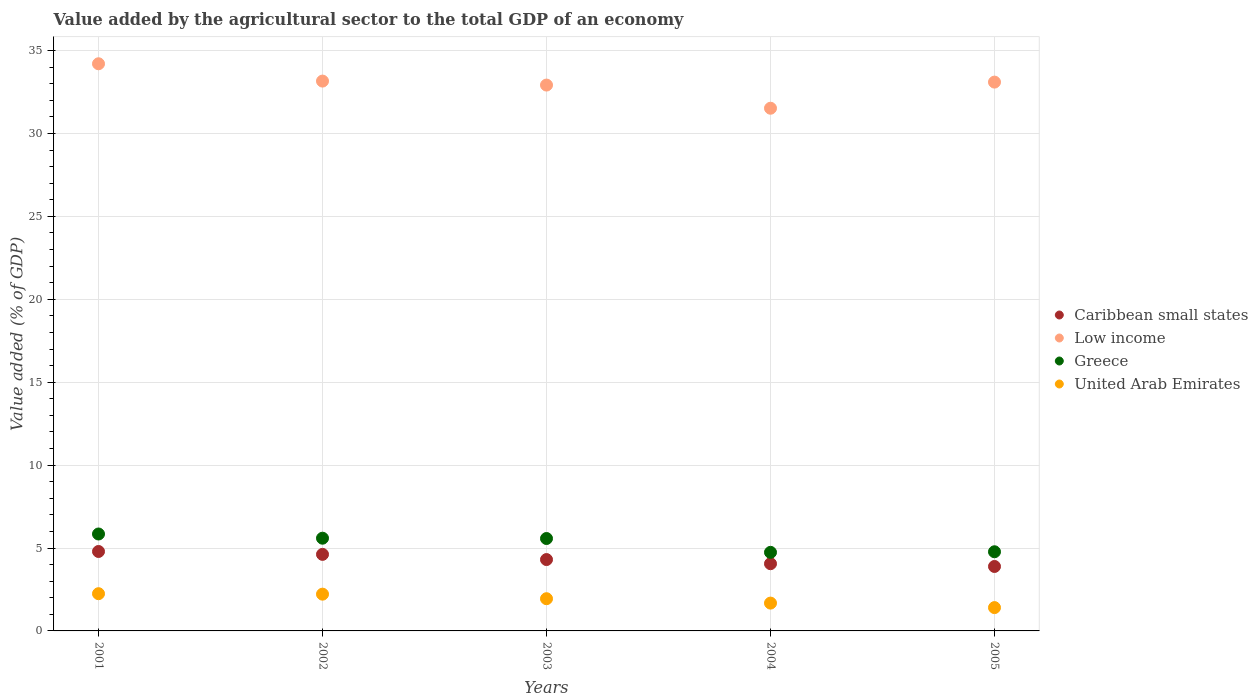How many different coloured dotlines are there?
Offer a terse response. 4. Is the number of dotlines equal to the number of legend labels?
Offer a terse response. Yes. What is the value added by the agricultural sector to the total GDP in Low income in 2005?
Offer a terse response. 33.1. Across all years, what is the maximum value added by the agricultural sector to the total GDP in Caribbean small states?
Your answer should be compact. 4.79. Across all years, what is the minimum value added by the agricultural sector to the total GDP in Caribbean small states?
Give a very brief answer. 3.89. In which year was the value added by the agricultural sector to the total GDP in United Arab Emirates maximum?
Make the answer very short. 2001. What is the total value added by the agricultural sector to the total GDP in Low income in the graph?
Keep it short and to the point. 164.89. What is the difference between the value added by the agricultural sector to the total GDP in Greece in 2003 and that in 2005?
Offer a terse response. 0.8. What is the difference between the value added by the agricultural sector to the total GDP in Caribbean small states in 2002 and the value added by the agricultural sector to the total GDP in Low income in 2005?
Keep it short and to the point. -28.48. What is the average value added by the agricultural sector to the total GDP in Low income per year?
Provide a succinct answer. 32.98. In the year 2003, what is the difference between the value added by the agricultural sector to the total GDP in Greece and value added by the agricultural sector to the total GDP in United Arab Emirates?
Make the answer very short. 3.63. In how many years, is the value added by the agricultural sector to the total GDP in Caribbean small states greater than 22 %?
Your response must be concise. 0. What is the ratio of the value added by the agricultural sector to the total GDP in Caribbean small states in 2002 to that in 2004?
Offer a terse response. 1.14. Is the value added by the agricultural sector to the total GDP in Caribbean small states in 2001 less than that in 2004?
Your answer should be very brief. No. What is the difference between the highest and the second highest value added by the agricultural sector to the total GDP in Greece?
Give a very brief answer. 0.25. What is the difference between the highest and the lowest value added by the agricultural sector to the total GDP in United Arab Emirates?
Keep it short and to the point. 0.84. In how many years, is the value added by the agricultural sector to the total GDP in Caribbean small states greater than the average value added by the agricultural sector to the total GDP in Caribbean small states taken over all years?
Provide a succinct answer. 2. Is the sum of the value added by the agricultural sector to the total GDP in United Arab Emirates in 2002 and 2005 greater than the maximum value added by the agricultural sector to the total GDP in Caribbean small states across all years?
Give a very brief answer. No. Is it the case that in every year, the sum of the value added by the agricultural sector to the total GDP in Greece and value added by the agricultural sector to the total GDP in United Arab Emirates  is greater than the sum of value added by the agricultural sector to the total GDP in Low income and value added by the agricultural sector to the total GDP in Caribbean small states?
Ensure brevity in your answer.  Yes. Does the value added by the agricultural sector to the total GDP in Greece monotonically increase over the years?
Give a very brief answer. No. Are the values on the major ticks of Y-axis written in scientific E-notation?
Offer a terse response. No. Where does the legend appear in the graph?
Your answer should be compact. Center right. How many legend labels are there?
Offer a terse response. 4. How are the legend labels stacked?
Your response must be concise. Vertical. What is the title of the graph?
Ensure brevity in your answer.  Value added by the agricultural sector to the total GDP of an economy. Does "Central African Republic" appear as one of the legend labels in the graph?
Ensure brevity in your answer.  No. What is the label or title of the Y-axis?
Your answer should be compact. Value added (% of GDP). What is the Value added (% of GDP) in Caribbean small states in 2001?
Offer a terse response. 4.79. What is the Value added (% of GDP) of Low income in 2001?
Offer a terse response. 34.2. What is the Value added (% of GDP) of Greece in 2001?
Provide a short and direct response. 5.84. What is the Value added (% of GDP) of United Arab Emirates in 2001?
Your answer should be compact. 2.25. What is the Value added (% of GDP) in Caribbean small states in 2002?
Your response must be concise. 4.62. What is the Value added (% of GDP) in Low income in 2002?
Provide a succinct answer. 33.16. What is the Value added (% of GDP) in Greece in 2002?
Provide a short and direct response. 5.59. What is the Value added (% of GDP) in United Arab Emirates in 2002?
Your answer should be compact. 2.22. What is the Value added (% of GDP) of Caribbean small states in 2003?
Offer a very short reply. 4.3. What is the Value added (% of GDP) of Low income in 2003?
Your answer should be very brief. 32.92. What is the Value added (% of GDP) of Greece in 2003?
Offer a very short reply. 5.57. What is the Value added (% of GDP) in United Arab Emirates in 2003?
Your response must be concise. 1.94. What is the Value added (% of GDP) in Caribbean small states in 2004?
Your answer should be compact. 4.05. What is the Value added (% of GDP) in Low income in 2004?
Your answer should be compact. 31.52. What is the Value added (% of GDP) of Greece in 2004?
Make the answer very short. 4.74. What is the Value added (% of GDP) of United Arab Emirates in 2004?
Give a very brief answer. 1.68. What is the Value added (% of GDP) in Caribbean small states in 2005?
Your response must be concise. 3.89. What is the Value added (% of GDP) in Low income in 2005?
Give a very brief answer. 33.1. What is the Value added (% of GDP) of Greece in 2005?
Your response must be concise. 4.77. What is the Value added (% of GDP) of United Arab Emirates in 2005?
Ensure brevity in your answer.  1.41. Across all years, what is the maximum Value added (% of GDP) in Caribbean small states?
Your response must be concise. 4.79. Across all years, what is the maximum Value added (% of GDP) in Low income?
Offer a terse response. 34.2. Across all years, what is the maximum Value added (% of GDP) in Greece?
Your response must be concise. 5.84. Across all years, what is the maximum Value added (% of GDP) of United Arab Emirates?
Ensure brevity in your answer.  2.25. Across all years, what is the minimum Value added (% of GDP) in Caribbean small states?
Your answer should be compact. 3.89. Across all years, what is the minimum Value added (% of GDP) of Low income?
Your answer should be very brief. 31.52. Across all years, what is the minimum Value added (% of GDP) in Greece?
Give a very brief answer. 4.74. Across all years, what is the minimum Value added (% of GDP) of United Arab Emirates?
Ensure brevity in your answer.  1.41. What is the total Value added (% of GDP) in Caribbean small states in the graph?
Give a very brief answer. 21.65. What is the total Value added (% of GDP) in Low income in the graph?
Offer a very short reply. 164.89. What is the total Value added (% of GDP) of Greece in the graph?
Offer a very short reply. 26.52. What is the total Value added (% of GDP) in United Arab Emirates in the graph?
Offer a terse response. 9.49. What is the difference between the Value added (% of GDP) of Caribbean small states in 2001 and that in 2002?
Give a very brief answer. 0.17. What is the difference between the Value added (% of GDP) in Low income in 2001 and that in 2002?
Keep it short and to the point. 1.04. What is the difference between the Value added (% of GDP) in Greece in 2001 and that in 2002?
Make the answer very short. 0.25. What is the difference between the Value added (% of GDP) in United Arab Emirates in 2001 and that in 2002?
Offer a very short reply. 0.03. What is the difference between the Value added (% of GDP) of Caribbean small states in 2001 and that in 2003?
Ensure brevity in your answer.  0.49. What is the difference between the Value added (% of GDP) of Low income in 2001 and that in 2003?
Provide a succinct answer. 1.28. What is the difference between the Value added (% of GDP) in Greece in 2001 and that in 2003?
Give a very brief answer. 0.27. What is the difference between the Value added (% of GDP) of United Arab Emirates in 2001 and that in 2003?
Your answer should be very brief. 0.3. What is the difference between the Value added (% of GDP) in Caribbean small states in 2001 and that in 2004?
Keep it short and to the point. 0.74. What is the difference between the Value added (% of GDP) in Low income in 2001 and that in 2004?
Make the answer very short. 2.68. What is the difference between the Value added (% of GDP) of Greece in 2001 and that in 2004?
Make the answer very short. 1.11. What is the difference between the Value added (% of GDP) in United Arab Emirates in 2001 and that in 2004?
Offer a very short reply. 0.57. What is the difference between the Value added (% of GDP) of Caribbean small states in 2001 and that in 2005?
Give a very brief answer. 0.9. What is the difference between the Value added (% of GDP) in Low income in 2001 and that in 2005?
Ensure brevity in your answer.  1.11. What is the difference between the Value added (% of GDP) in Greece in 2001 and that in 2005?
Provide a short and direct response. 1.07. What is the difference between the Value added (% of GDP) of United Arab Emirates in 2001 and that in 2005?
Your answer should be very brief. 0.84. What is the difference between the Value added (% of GDP) of Caribbean small states in 2002 and that in 2003?
Your response must be concise. 0.31. What is the difference between the Value added (% of GDP) in Low income in 2002 and that in 2003?
Offer a very short reply. 0.24. What is the difference between the Value added (% of GDP) of Greece in 2002 and that in 2003?
Offer a very short reply. 0.02. What is the difference between the Value added (% of GDP) in United Arab Emirates in 2002 and that in 2003?
Give a very brief answer. 0.27. What is the difference between the Value added (% of GDP) in Caribbean small states in 2002 and that in 2004?
Your response must be concise. 0.56. What is the difference between the Value added (% of GDP) of Low income in 2002 and that in 2004?
Keep it short and to the point. 1.64. What is the difference between the Value added (% of GDP) in Greece in 2002 and that in 2004?
Your answer should be very brief. 0.85. What is the difference between the Value added (% of GDP) of United Arab Emirates in 2002 and that in 2004?
Your response must be concise. 0.54. What is the difference between the Value added (% of GDP) in Caribbean small states in 2002 and that in 2005?
Provide a short and direct response. 0.73. What is the difference between the Value added (% of GDP) of Low income in 2002 and that in 2005?
Ensure brevity in your answer.  0.06. What is the difference between the Value added (% of GDP) of Greece in 2002 and that in 2005?
Your response must be concise. 0.82. What is the difference between the Value added (% of GDP) of United Arab Emirates in 2002 and that in 2005?
Ensure brevity in your answer.  0.81. What is the difference between the Value added (% of GDP) of Caribbean small states in 2003 and that in 2004?
Provide a succinct answer. 0.25. What is the difference between the Value added (% of GDP) in Low income in 2003 and that in 2004?
Ensure brevity in your answer.  1.4. What is the difference between the Value added (% of GDP) of Greece in 2003 and that in 2004?
Keep it short and to the point. 0.83. What is the difference between the Value added (% of GDP) in United Arab Emirates in 2003 and that in 2004?
Keep it short and to the point. 0.26. What is the difference between the Value added (% of GDP) of Caribbean small states in 2003 and that in 2005?
Ensure brevity in your answer.  0.42. What is the difference between the Value added (% of GDP) of Low income in 2003 and that in 2005?
Your answer should be compact. -0.18. What is the difference between the Value added (% of GDP) in Greece in 2003 and that in 2005?
Keep it short and to the point. 0.8. What is the difference between the Value added (% of GDP) in United Arab Emirates in 2003 and that in 2005?
Provide a short and direct response. 0.54. What is the difference between the Value added (% of GDP) in Caribbean small states in 2004 and that in 2005?
Provide a short and direct response. 0.17. What is the difference between the Value added (% of GDP) of Low income in 2004 and that in 2005?
Keep it short and to the point. -1.58. What is the difference between the Value added (% of GDP) of Greece in 2004 and that in 2005?
Make the answer very short. -0.03. What is the difference between the Value added (% of GDP) of United Arab Emirates in 2004 and that in 2005?
Your response must be concise. 0.27. What is the difference between the Value added (% of GDP) in Caribbean small states in 2001 and the Value added (% of GDP) in Low income in 2002?
Offer a terse response. -28.37. What is the difference between the Value added (% of GDP) in Caribbean small states in 2001 and the Value added (% of GDP) in Greece in 2002?
Your answer should be very brief. -0.8. What is the difference between the Value added (% of GDP) of Caribbean small states in 2001 and the Value added (% of GDP) of United Arab Emirates in 2002?
Ensure brevity in your answer.  2.57. What is the difference between the Value added (% of GDP) of Low income in 2001 and the Value added (% of GDP) of Greece in 2002?
Offer a terse response. 28.61. What is the difference between the Value added (% of GDP) in Low income in 2001 and the Value added (% of GDP) in United Arab Emirates in 2002?
Offer a very short reply. 31.98. What is the difference between the Value added (% of GDP) of Greece in 2001 and the Value added (% of GDP) of United Arab Emirates in 2002?
Provide a short and direct response. 3.63. What is the difference between the Value added (% of GDP) of Caribbean small states in 2001 and the Value added (% of GDP) of Low income in 2003?
Provide a short and direct response. -28.13. What is the difference between the Value added (% of GDP) of Caribbean small states in 2001 and the Value added (% of GDP) of Greece in 2003?
Provide a succinct answer. -0.78. What is the difference between the Value added (% of GDP) of Caribbean small states in 2001 and the Value added (% of GDP) of United Arab Emirates in 2003?
Your answer should be very brief. 2.85. What is the difference between the Value added (% of GDP) of Low income in 2001 and the Value added (% of GDP) of Greece in 2003?
Your answer should be compact. 28.63. What is the difference between the Value added (% of GDP) in Low income in 2001 and the Value added (% of GDP) in United Arab Emirates in 2003?
Provide a succinct answer. 32.26. What is the difference between the Value added (% of GDP) of Greece in 2001 and the Value added (% of GDP) of United Arab Emirates in 2003?
Ensure brevity in your answer.  3.9. What is the difference between the Value added (% of GDP) in Caribbean small states in 2001 and the Value added (% of GDP) in Low income in 2004?
Your answer should be compact. -26.73. What is the difference between the Value added (% of GDP) in Caribbean small states in 2001 and the Value added (% of GDP) in Greece in 2004?
Provide a succinct answer. 0.05. What is the difference between the Value added (% of GDP) of Caribbean small states in 2001 and the Value added (% of GDP) of United Arab Emirates in 2004?
Your answer should be very brief. 3.11. What is the difference between the Value added (% of GDP) of Low income in 2001 and the Value added (% of GDP) of Greece in 2004?
Your answer should be compact. 29.46. What is the difference between the Value added (% of GDP) of Low income in 2001 and the Value added (% of GDP) of United Arab Emirates in 2004?
Make the answer very short. 32.52. What is the difference between the Value added (% of GDP) in Greece in 2001 and the Value added (% of GDP) in United Arab Emirates in 2004?
Make the answer very short. 4.17. What is the difference between the Value added (% of GDP) of Caribbean small states in 2001 and the Value added (% of GDP) of Low income in 2005?
Offer a very short reply. -28.31. What is the difference between the Value added (% of GDP) in Caribbean small states in 2001 and the Value added (% of GDP) in Greece in 2005?
Your answer should be compact. 0.02. What is the difference between the Value added (% of GDP) in Caribbean small states in 2001 and the Value added (% of GDP) in United Arab Emirates in 2005?
Offer a very short reply. 3.38. What is the difference between the Value added (% of GDP) in Low income in 2001 and the Value added (% of GDP) in Greece in 2005?
Your response must be concise. 29.43. What is the difference between the Value added (% of GDP) of Low income in 2001 and the Value added (% of GDP) of United Arab Emirates in 2005?
Offer a terse response. 32.8. What is the difference between the Value added (% of GDP) of Greece in 2001 and the Value added (% of GDP) of United Arab Emirates in 2005?
Keep it short and to the point. 4.44. What is the difference between the Value added (% of GDP) of Caribbean small states in 2002 and the Value added (% of GDP) of Low income in 2003?
Your response must be concise. -28.3. What is the difference between the Value added (% of GDP) in Caribbean small states in 2002 and the Value added (% of GDP) in Greece in 2003?
Give a very brief answer. -0.96. What is the difference between the Value added (% of GDP) in Caribbean small states in 2002 and the Value added (% of GDP) in United Arab Emirates in 2003?
Ensure brevity in your answer.  2.67. What is the difference between the Value added (% of GDP) of Low income in 2002 and the Value added (% of GDP) of Greece in 2003?
Provide a succinct answer. 27.58. What is the difference between the Value added (% of GDP) in Low income in 2002 and the Value added (% of GDP) in United Arab Emirates in 2003?
Make the answer very short. 31.21. What is the difference between the Value added (% of GDP) in Greece in 2002 and the Value added (% of GDP) in United Arab Emirates in 2003?
Your response must be concise. 3.65. What is the difference between the Value added (% of GDP) of Caribbean small states in 2002 and the Value added (% of GDP) of Low income in 2004?
Give a very brief answer. -26.9. What is the difference between the Value added (% of GDP) in Caribbean small states in 2002 and the Value added (% of GDP) in Greece in 2004?
Offer a terse response. -0.12. What is the difference between the Value added (% of GDP) in Caribbean small states in 2002 and the Value added (% of GDP) in United Arab Emirates in 2004?
Ensure brevity in your answer.  2.94. What is the difference between the Value added (% of GDP) of Low income in 2002 and the Value added (% of GDP) of Greece in 2004?
Ensure brevity in your answer.  28.42. What is the difference between the Value added (% of GDP) of Low income in 2002 and the Value added (% of GDP) of United Arab Emirates in 2004?
Offer a terse response. 31.48. What is the difference between the Value added (% of GDP) of Greece in 2002 and the Value added (% of GDP) of United Arab Emirates in 2004?
Your answer should be very brief. 3.91. What is the difference between the Value added (% of GDP) of Caribbean small states in 2002 and the Value added (% of GDP) of Low income in 2005?
Offer a terse response. -28.48. What is the difference between the Value added (% of GDP) in Caribbean small states in 2002 and the Value added (% of GDP) in Greece in 2005?
Give a very brief answer. -0.16. What is the difference between the Value added (% of GDP) of Caribbean small states in 2002 and the Value added (% of GDP) of United Arab Emirates in 2005?
Offer a terse response. 3.21. What is the difference between the Value added (% of GDP) in Low income in 2002 and the Value added (% of GDP) in Greece in 2005?
Your answer should be very brief. 28.38. What is the difference between the Value added (% of GDP) of Low income in 2002 and the Value added (% of GDP) of United Arab Emirates in 2005?
Give a very brief answer. 31.75. What is the difference between the Value added (% of GDP) in Greece in 2002 and the Value added (% of GDP) in United Arab Emirates in 2005?
Ensure brevity in your answer.  4.19. What is the difference between the Value added (% of GDP) of Caribbean small states in 2003 and the Value added (% of GDP) of Low income in 2004?
Your answer should be compact. -27.22. What is the difference between the Value added (% of GDP) of Caribbean small states in 2003 and the Value added (% of GDP) of Greece in 2004?
Your response must be concise. -0.44. What is the difference between the Value added (% of GDP) in Caribbean small states in 2003 and the Value added (% of GDP) in United Arab Emirates in 2004?
Your answer should be compact. 2.63. What is the difference between the Value added (% of GDP) in Low income in 2003 and the Value added (% of GDP) in Greece in 2004?
Your answer should be very brief. 28.18. What is the difference between the Value added (% of GDP) of Low income in 2003 and the Value added (% of GDP) of United Arab Emirates in 2004?
Keep it short and to the point. 31.24. What is the difference between the Value added (% of GDP) of Greece in 2003 and the Value added (% of GDP) of United Arab Emirates in 2004?
Give a very brief answer. 3.9. What is the difference between the Value added (% of GDP) of Caribbean small states in 2003 and the Value added (% of GDP) of Low income in 2005?
Your answer should be compact. -28.79. What is the difference between the Value added (% of GDP) in Caribbean small states in 2003 and the Value added (% of GDP) in Greece in 2005?
Your answer should be very brief. -0.47. What is the difference between the Value added (% of GDP) in Caribbean small states in 2003 and the Value added (% of GDP) in United Arab Emirates in 2005?
Your response must be concise. 2.9. What is the difference between the Value added (% of GDP) in Low income in 2003 and the Value added (% of GDP) in Greece in 2005?
Your response must be concise. 28.14. What is the difference between the Value added (% of GDP) of Low income in 2003 and the Value added (% of GDP) of United Arab Emirates in 2005?
Give a very brief answer. 31.51. What is the difference between the Value added (% of GDP) in Greece in 2003 and the Value added (% of GDP) in United Arab Emirates in 2005?
Your answer should be very brief. 4.17. What is the difference between the Value added (% of GDP) in Caribbean small states in 2004 and the Value added (% of GDP) in Low income in 2005?
Provide a short and direct response. -29.04. What is the difference between the Value added (% of GDP) of Caribbean small states in 2004 and the Value added (% of GDP) of Greece in 2005?
Keep it short and to the point. -0.72. What is the difference between the Value added (% of GDP) in Caribbean small states in 2004 and the Value added (% of GDP) in United Arab Emirates in 2005?
Offer a very short reply. 2.65. What is the difference between the Value added (% of GDP) in Low income in 2004 and the Value added (% of GDP) in Greece in 2005?
Give a very brief answer. 26.75. What is the difference between the Value added (% of GDP) of Low income in 2004 and the Value added (% of GDP) of United Arab Emirates in 2005?
Make the answer very short. 30.11. What is the difference between the Value added (% of GDP) in Greece in 2004 and the Value added (% of GDP) in United Arab Emirates in 2005?
Give a very brief answer. 3.33. What is the average Value added (% of GDP) in Caribbean small states per year?
Provide a succinct answer. 4.33. What is the average Value added (% of GDP) of Low income per year?
Keep it short and to the point. 32.98. What is the average Value added (% of GDP) in Greece per year?
Your answer should be very brief. 5.3. What is the average Value added (% of GDP) in United Arab Emirates per year?
Give a very brief answer. 1.9. In the year 2001, what is the difference between the Value added (% of GDP) in Caribbean small states and Value added (% of GDP) in Low income?
Your answer should be very brief. -29.41. In the year 2001, what is the difference between the Value added (% of GDP) of Caribbean small states and Value added (% of GDP) of Greece?
Provide a short and direct response. -1.05. In the year 2001, what is the difference between the Value added (% of GDP) in Caribbean small states and Value added (% of GDP) in United Arab Emirates?
Offer a very short reply. 2.55. In the year 2001, what is the difference between the Value added (% of GDP) in Low income and Value added (% of GDP) in Greece?
Keep it short and to the point. 28.36. In the year 2001, what is the difference between the Value added (% of GDP) in Low income and Value added (% of GDP) in United Arab Emirates?
Offer a very short reply. 31.96. In the year 2001, what is the difference between the Value added (% of GDP) of Greece and Value added (% of GDP) of United Arab Emirates?
Your answer should be very brief. 3.6. In the year 2002, what is the difference between the Value added (% of GDP) in Caribbean small states and Value added (% of GDP) in Low income?
Keep it short and to the point. -28.54. In the year 2002, what is the difference between the Value added (% of GDP) in Caribbean small states and Value added (% of GDP) in Greece?
Make the answer very short. -0.98. In the year 2002, what is the difference between the Value added (% of GDP) in Caribbean small states and Value added (% of GDP) in United Arab Emirates?
Offer a terse response. 2.4. In the year 2002, what is the difference between the Value added (% of GDP) of Low income and Value added (% of GDP) of Greece?
Your answer should be compact. 27.57. In the year 2002, what is the difference between the Value added (% of GDP) of Low income and Value added (% of GDP) of United Arab Emirates?
Keep it short and to the point. 30.94. In the year 2002, what is the difference between the Value added (% of GDP) in Greece and Value added (% of GDP) in United Arab Emirates?
Your response must be concise. 3.37. In the year 2003, what is the difference between the Value added (% of GDP) of Caribbean small states and Value added (% of GDP) of Low income?
Offer a terse response. -28.61. In the year 2003, what is the difference between the Value added (% of GDP) in Caribbean small states and Value added (% of GDP) in Greece?
Make the answer very short. -1.27. In the year 2003, what is the difference between the Value added (% of GDP) in Caribbean small states and Value added (% of GDP) in United Arab Emirates?
Keep it short and to the point. 2.36. In the year 2003, what is the difference between the Value added (% of GDP) of Low income and Value added (% of GDP) of Greece?
Your answer should be compact. 27.34. In the year 2003, what is the difference between the Value added (% of GDP) of Low income and Value added (% of GDP) of United Arab Emirates?
Keep it short and to the point. 30.98. In the year 2003, what is the difference between the Value added (% of GDP) in Greece and Value added (% of GDP) in United Arab Emirates?
Offer a very short reply. 3.63. In the year 2004, what is the difference between the Value added (% of GDP) in Caribbean small states and Value added (% of GDP) in Low income?
Provide a short and direct response. -27.47. In the year 2004, what is the difference between the Value added (% of GDP) of Caribbean small states and Value added (% of GDP) of Greece?
Your response must be concise. -0.69. In the year 2004, what is the difference between the Value added (% of GDP) in Caribbean small states and Value added (% of GDP) in United Arab Emirates?
Keep it short and to the point. 2.38. In the year 2004, what is the difference between the Value added (% of GDP) of Low income and Value added (% of GDP) of Greece?
Keep it short and to the point. 26.78. In the year 2004, what is the difference between the Value added (% of GDP) in Low income and Value added (% of GDP) in United Arab Emirates?
Ensure brevity in your answer.  29.84. In the year 2004, what is the difference between the Value added (% of GDP) in Greece and Value added (% of GDP) in United Arab Emirates?
Keep it short and to the point. 3.06. In the year 2005, what is the difference between the Value added (% of GDP) in Caribbean small states and Value added (% of GDP) in Low income?
Offer a very short reply. -29.21. In the year 2005, what is the difference between the Value added (% of GDP) of Caribbean small states and Value added (% of GDP) of Greece?
Your answer should be compact. -0.89. In the year 2005, what is the difference between the Value added (% of GDP) in Caribbean small states and Value added (% of GDP) in United Arab Emirates?
Your response must be concise. 2.48. In the year 2005, what is the difference between the Value added (% of GDP) of Low income and Value added (% of GDP) of Greece?
Ensure brevity in your answer.  28.32. In the year 2005, what is the difference between the Value added (% of GDP) in Low income and Value added (% of GDP) in United Arab Emirates?
Your response must be concise. 31.69. In the year 2005, what is the difference between the Value added (% of GDP) in Greece and Value added (% of GDP) in United Arab Emirates?
Provide a succinct answer. 3.37. What is the ratio of the Value added (% of GDP) in Caribbean small states in 2001 to that in 2002?
Provide a succinct answer. 1.04. What is the ratio of the Value added (% of GDP) in Low income in 2001 to that in 2002?
Provide a short and direct response. 1.03. What is the ratio of the Value added (% of GDP) in Greece in 2001 to that in 2002?
Ensure brevity in your answer.  1.05. What is the ratio of the Value added (% of GDP) in United Arab Emirates in 2001 to that in 2002?
Offer a very short reply. 1.01. What is the ratio of the Value added (% of GDP) of Caribbean small states in 2001 to that in 2003?
Provide a short and direct response. 1.11. What is the ratio of the Value added (% of GDP) of Low income in 2001 to that in 2003?
Offer a terse response. 1.04. What is the ratio of the Value added (% of GDP) of Greece in 2001 to that in 2003?
Keep it short and to the point. 1.05. What is the ratio of the Value added (% of GDP) of United Arab Emirates in 2001 to that in 2003?
Make the answer very short. 1.16. What is the ratio of the Value added (% of GDP) of Caribbean small states in 2001 to that in 2004?
Your answer should be very brief. 1.18. What is the ratio of the Value added (% of GDP) in Low income in 2001 to that in 2004?
Give a very brief answer. 1.09. What is the ratio of the Value added (% of GDP) of Greece in 2001 to that in 2004?
Make the answer very short. 1.23. What is the ratio of the Value added (% of GDP) of United Arab Emirates in 2001 to that in 2004?
Make the answer very short. 1.34. What is the ratio of the Value added (% of GDP) of Caribbean small states in 2001 to that in 2005?
Your answer should be compact. 1.23. What is the ratio of the Value added (% of GDP) of Low income in 2001 to that in 2005?
Provide a short and direct response. 1.03. What is the ratio of the Value added (% of GDP) of Greece in 2001 to that in 2005?
Your response must be concise. 1.22. What is the ratio of the Value added (% of GDP) in United Arab Emirates in 2001 to that in 2005?
Offer a terse response. 1.6. What is the ratio of the Value added (% of GDP) of Caribbean small states in 2002 to that in 2003?
Provide a short and direct response. 1.07. What is the ratio of the Value added (% of GDP) of Low income in 2002 to that in 2003?
Ensure brevity in your answer.  1.01. What is the ratio of the Value added (% of GDP) of Greece in 2002 to that in 2003?
Offer a terse response. 1. What is the ratio of the Value added (% of GDP) in United Arab Emirates in 2002 to that in 2003?
Keep it short and to the point. 1.14. What is the ratio of the Value added (% of GDP) of Caribbean small states in 2002 to that in 2004?
Your answer should be compact. 1.14. What is the ratio of the Value added (% of GDP) of Low income in 2002 to that in 2004?
Make the answer very short. 1.05. What is the ratio of the Value added (% of GDP) in Greece in 2002 to that in 2004?
Offer a terse response. 1.18. What is the ratio of the Value added (% of GDP) of United Arab Emirates in 2002 to that in 2004?
Your answer should be very brief. 1.32. What is the ratio of the Value added (% of GDP) in Caribbean small states in 2002 to that in 2005?
Keep it short and to the point. 1.19. What is the ratio of the Value added (% of GDP) of Low income in 2002 to that in 2005?
Keep it short and to the point. 1. What is the ratio of the Value added (% of GDP) in Greece in 2002 to that in 2005?
Your response must be concise. 1.17. What is the ratio of the Value added (% of GDP) in United Arab Emirates in 2002 to that in 2005?
Keep it short and to the point. 1.58. What is the ratio of the Value added (% of GDP) in Caribbean small states in 2003 to that in 2004?
Provide a short and direct response. 1.06. What is the ratio of the Value added (% of GDP) of Low income in 2003 to that in 2004?
Provide a short and direct response. 1.04. What is the ratio of the Value added (% of GDP) in Greece in 2003 to that in 2004?
Provide a short and direct response. 1.18. What is the ratio of the Value added (% of GDP) in United Arab Emirates in 2003 to that in 2004?
Make the answer very short. 1.16. What is the ratio of the Value added (% of GDP) in Caribbean small states in 2003 to that in 2005?
Your answer should be compact. 1.11. What is the ratio of the Value added (% of GDP) of Greece in 2003 to that in 2005?
Your answer should be compact. 1.17. What is the ratio of the Value added (% of GDP) of United Arab Emirates in 2003 to that in 2005?
Make the answer very short. 1.38. What is the ratio of the Value added (% of GDP) in Caribbean small states in 2004 to that in 2005?
Your response must be concise. 1.04. What is the ratio of the Value added (% of GDP) of Low income in 2004 to that in 2005?
Your answer should be compact. 0.95. What is the ratio of the Value added (% of GDP) in Greece in 2004 to that in 2005?
Offer a terse response. 0.99. What is the ratio of the Value added (% of GDP) of United Arab Emirates in 2004 to that in 2005?
Offer a very short reply. 1.19. What is the difference between the highest and the second highest Value added (% of GDP) in Caribbean small states?
Provide a short and direct response. 0.17. What is the difference between the highest and the second highest Value added (% of GDP) in Low income?
Your answer should be very brief. 1.04. What is the difference between the highest and the second highest Value added (% of GDP) of Greece?
Make the answer very short. 0.25. What is the difference between the highest and the second highest Value added (% of GDP) in United Arab Emirates?
Provide a succinct answer. 0.03. What is the difference between the highest and the lowest Value added (% of GDP) in Caribbean small states?
Make the answer very short. 0.9. What is the difference between the highest and the lowest Value added (% of GDP) of Low income?
Give a very brief answer. 2.68. What is the difference between the highest and the lowest Value added (% of GDP) in Greece?
Offer a very short reply. 1.11. What is the difference between the highest and the lowest Value added (% of GDP) in United Arab Emirates?
Ensure brevity in your answer.  0.84. 